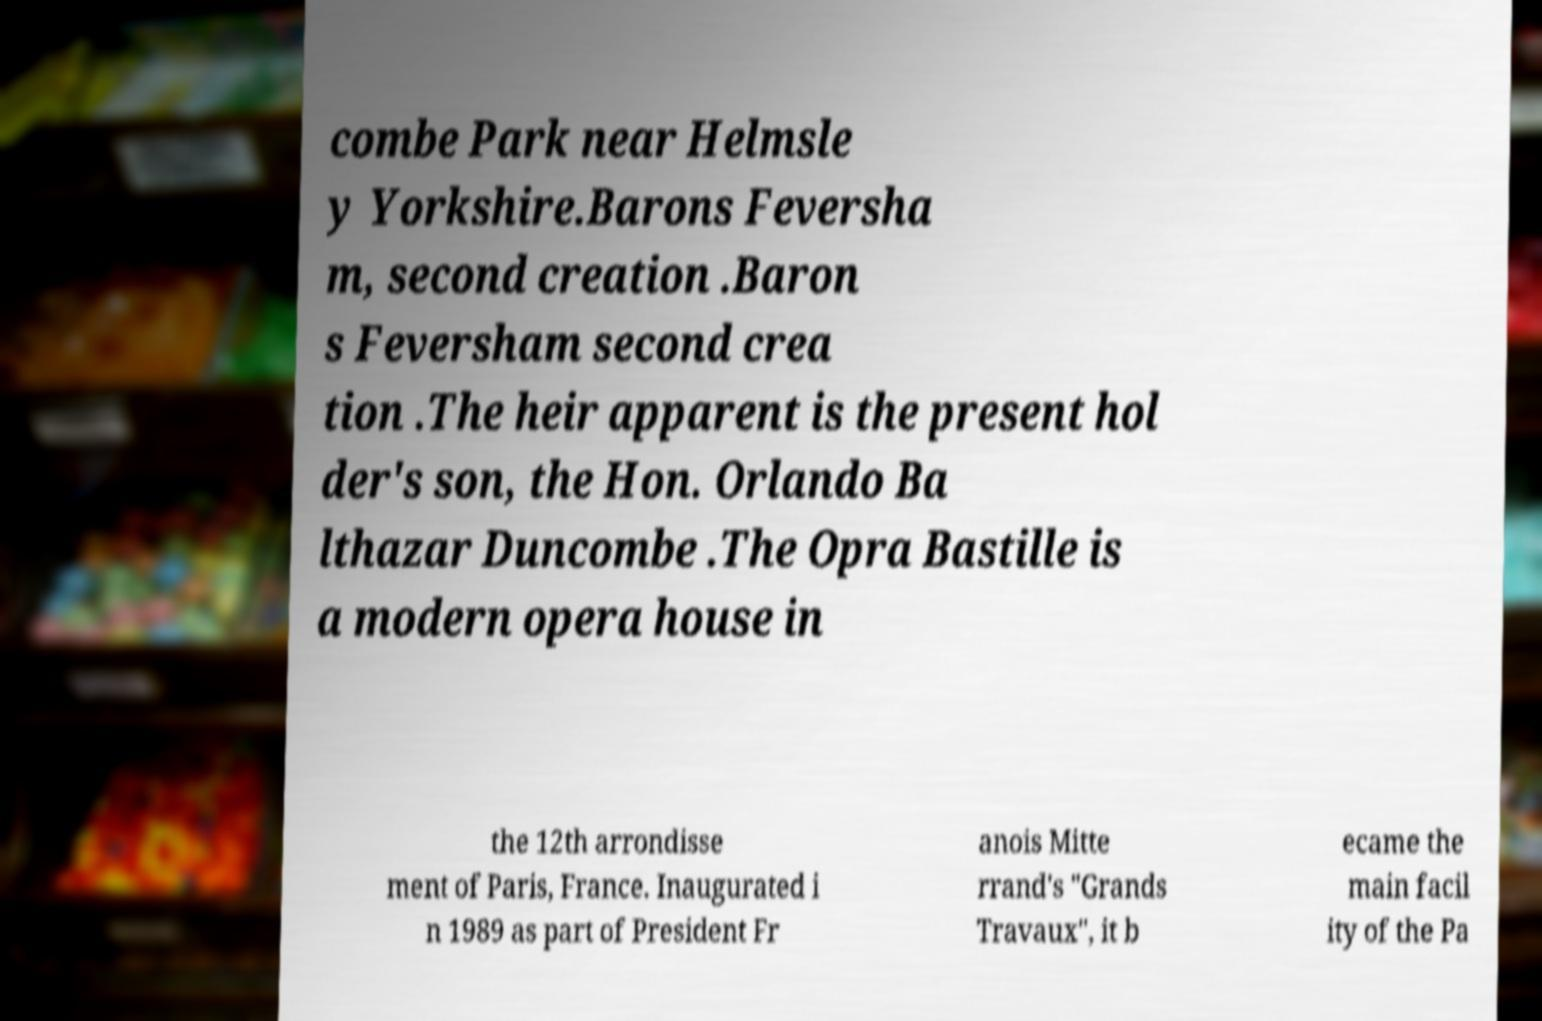Please read and relay the text visible in this image. What does it say? combe Park near Helmsle y Yorkshire.Barons Feversha m, second creation .Baron s Feversham second crea tion .The heir apparent is the present hol der's son, the Hon. Orlando Ba lthazar Duncombe .The Opra Bastille is a modern opera house in the 12th arrondisse ment of Paris, France. Inaugurated i n 1989 as part of President Fr anois Mitte rrand's "Grands Travaux", it b ecame the main facil ity of the Pa 